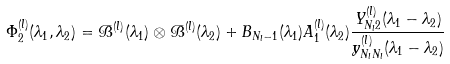Convert formula to latex. <formula><loc_0><loc_0><loc_500><loc_500>\Phi _ { 2 } ^ { ( l ) } ( \lambda _ { 1 } , \lambda _ { 2 } ) = \mathcal { B } ^ { ( l ) } ( \lambda _ { 1 } ) \otimes \mathcal { B } ^ { ( l ) } ( \lambda _ { 2 } ) + B _ { N _ { l } - 1 } ( \lambda _ { 1 } ) A _ { 1 } ^ { ( l ) } ( \lambda _ { 2 } ) \frac { Y _ { N _ { l } 2 } ^ { ( l ) } ( \lambda _ { 1 } - \lambda _ { 2 } ) } { y _ { N _ { l } N _ { l } } ^ { ( l ) } ( \lambda _ { 1 } - \lambda _ { 2 } ) }</formula> 